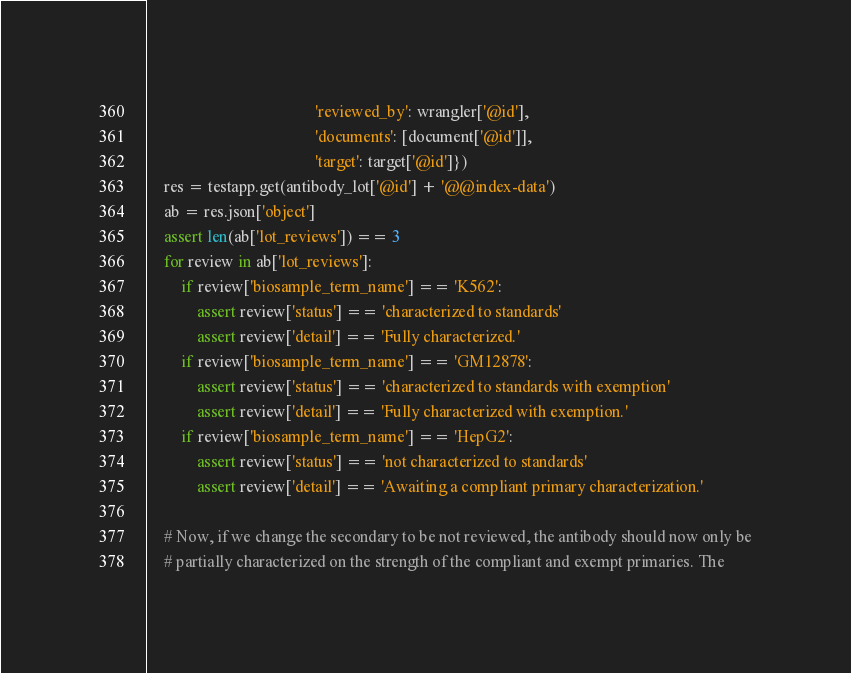Convert code to text. <code><loc_0><loc_0><loc_500><loc_500><_Python_>                                         'reviewed_by': wrangler['@id'],
                                         'documents': [document['@id']],
                                         'target': target['@id']})
    res = testapp.get(antibody_lot['@id'] + '@@index-data')
    ab = res.json['object']
    assert len(ab['lot_reviews']) == 3
    for review in ab['lot_reviews']:
        if review['biosample_term_name'] == 'K562':
            assert review['status'] == 'characterized to standards'
            assert review['detail'] == 'Fully characterized.'
        if review['biosample_term_name'] == 'GM12878':
            assert review['status'] == 'characterized to standards with exemption'
            assert review['detail'] == 'Fully characterized with exemption.'
        if review['biosample_term_name'] == 'HepG2':
            assert review['status'] == 'not characterized to standards'
            assert review['detail'] == 'Awaiting a compliant primary characterization.'

    # Now, if we change the secondary to be not reviewed, the antibody should now only be
    # partially characterized on the strength of the compliant and exempt primaries. The</code> 